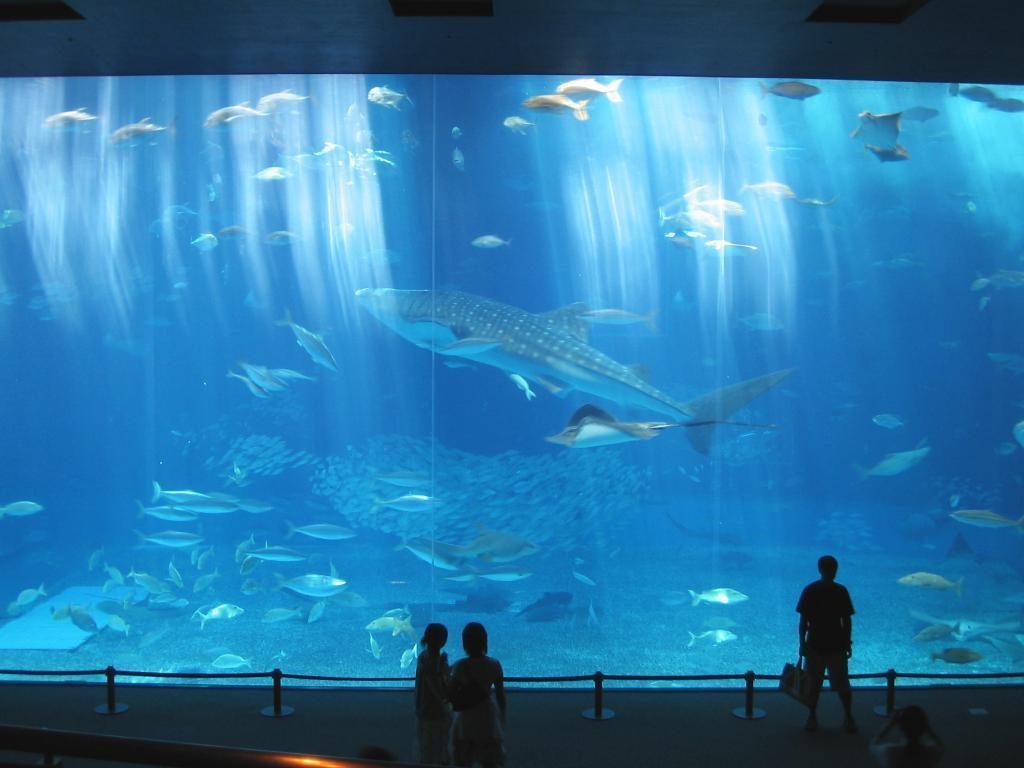What is the main object in the image? There is a big glass in the image. What is inside the big glass? The big glass contains water. What can be found in the water? There are fishes in the water. What are the people nearby doing? The people standing nearby are watching. What type of leather is visible in the image? There is no leather present in the image. Can you describe the ocean in the image? There is no ocean present in the image; it features a big glass with water and fishes. 